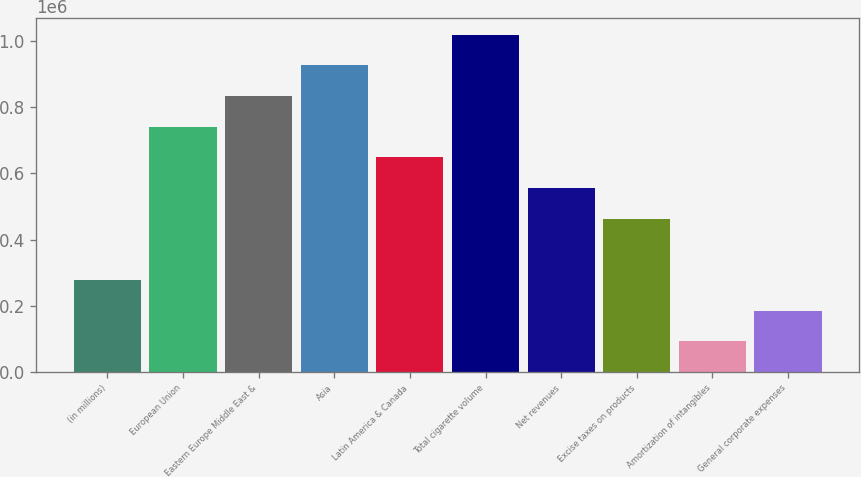<chart> <loc_0><loc_0><loc_500><loc_500><bar_chart><fcel>(in millions)<fcel>European Union<fcel>Eastern Europe Middle East &<fcel>Asia<fcel>Latin America & Canada<fcel>Total cigarette volume<fcel>Net revenues<fcel>Excise taxes on products<fcel>Amortization of intangibles<fcel>General corporate expenses<nl><fcel>278123<fcel>741632<fcel>834334<fcel>927036<fcel>648930<fcel>1.01974e+06<fcel>556228<fcel>463526<fcel>92718.9<fcel>185421<nl></chart> 